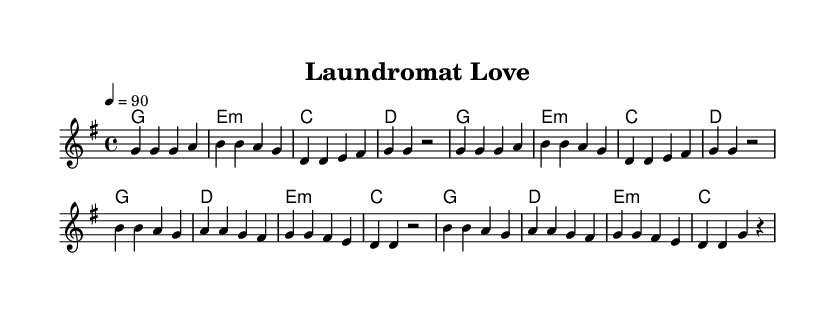What is the key signature of this music? The key signature is G major, indicated by an F# in the staff at the beginning of the piece.
Answer: G major What is the time signature of this music? The time signature is 4/4, which is noted at the beginning of the score and indicates four beats per measure.
Answer: 4/4 What is the tempo marking for this piece? The tempo is marked as 90 beats per minute, shown in the score as "4 = 90," specifying the speed at which to play.
Answer: 90 How many measures are in the verse section? By counting the measures in the first labeled section (the verse), there are eight measures before the chorus begins.
Answer: 8 What is the first chord played in this piece? The first chord shown is G major, which is represented as "g1" in the harmonies section, indicating it is played for the whole measure.
Answer: G What unique musical element reflects Rhythm and Blues in this piece? The combination of repetitive melodic lines in the verses and a catchy, romantic theme about everyday life situations is characteristic of Rhythm and Blues, which reflects a relatable emotional connection.
Answer: Repetitive melodic lines What is the overall theme of the lyrics? The lyrics focus on a whimsical romantic encounter at a laundromat, celebrating quirky and everyday moments of life and love.
Answer: Romantic encounter 